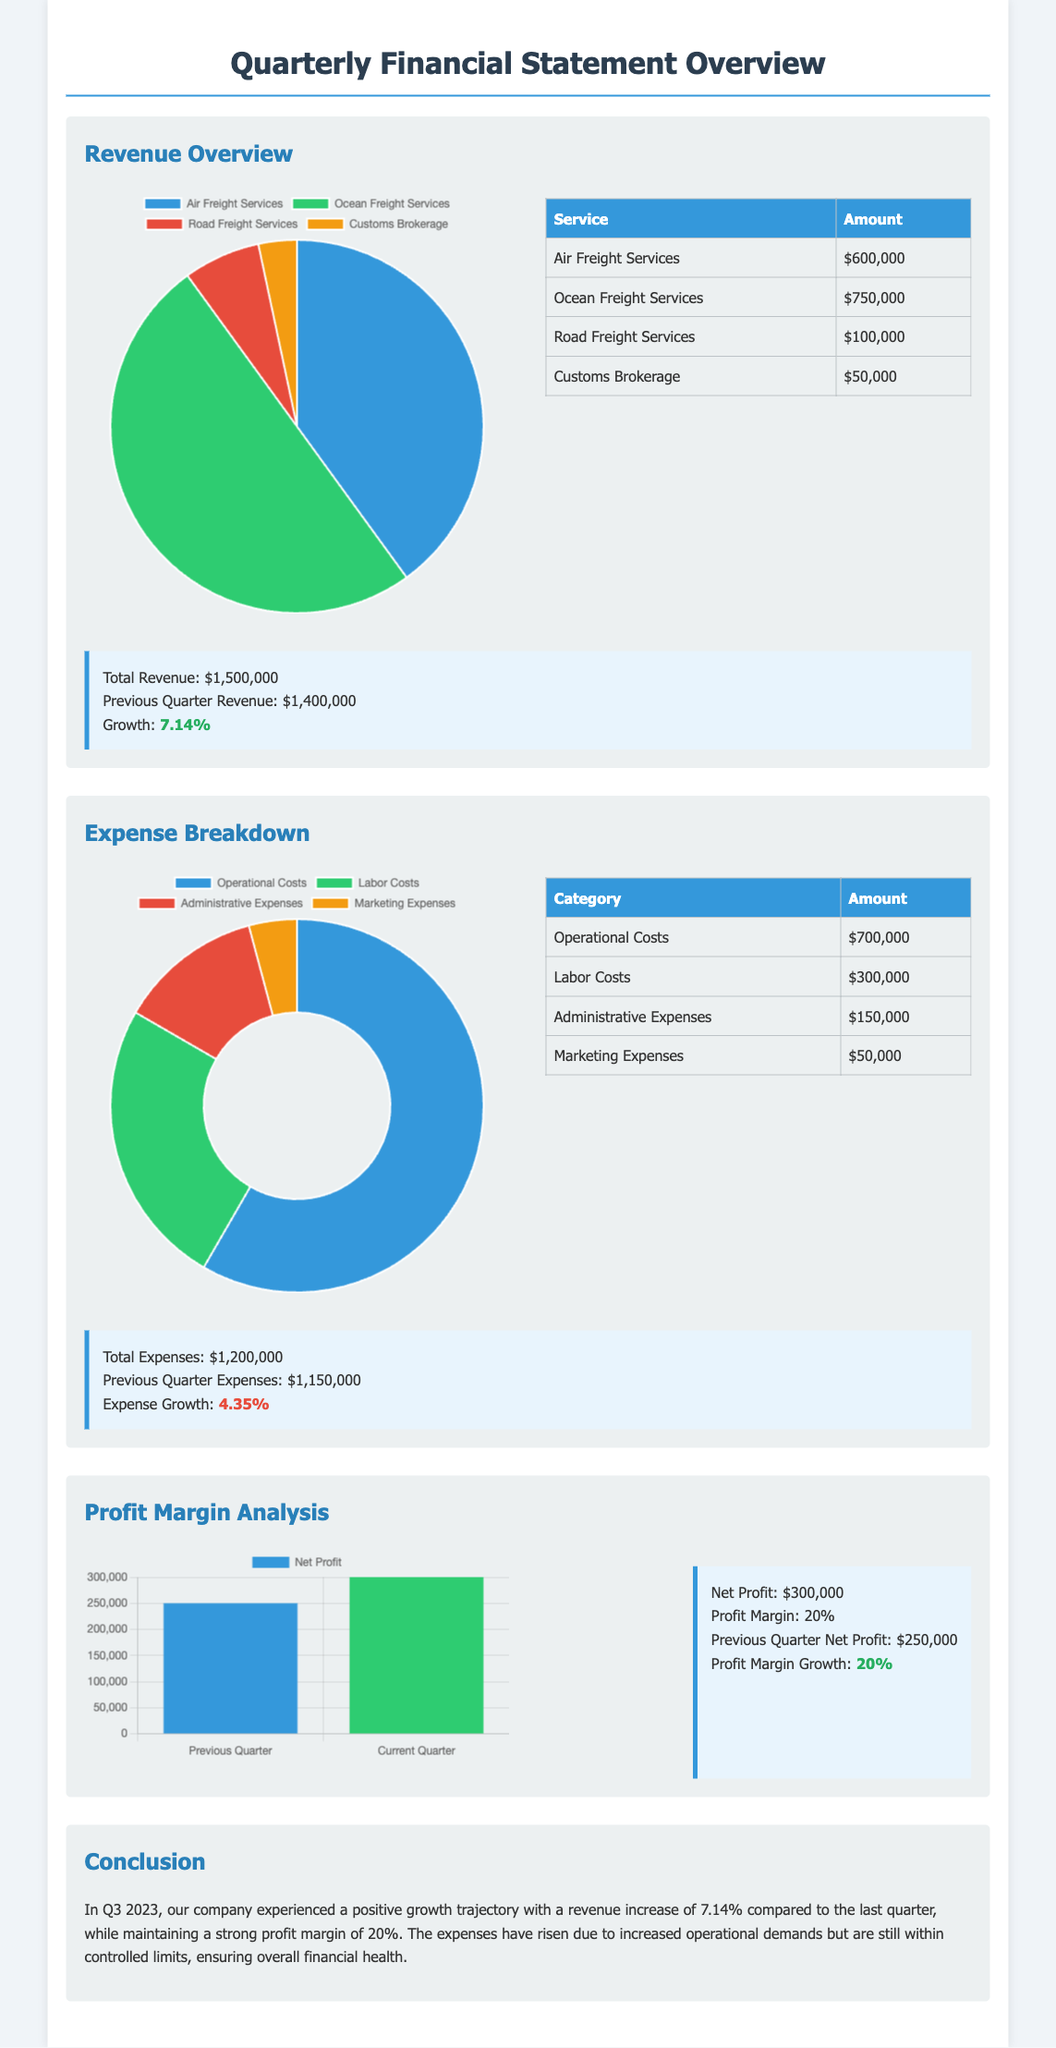What is the total revenue? The total revenue is provided in the summary section where all revenue sources are added up to $1,500,000.
Answer: $1,500,000 What is the growth percentage of revenue? The growth percentage of revenue is mentioned in the summary, comparing the current quarter to the previous quarter, which is 7.14%.
Answer: 7.14% What are the total expenses? The total expenses are listed in the summary section as being $1,200,000.
Answer: $1,200,000 Which service generated the highest revenue? The service with the highest revenue is found in the revenue breakdown, which is Ocean Freight Services with $750,000.
Answer: Ocean Freight Services What was the net profit for the current quarter? The net profit is detailed in the profit margin analysis section as $300,000.
Answer: $300,000 What is the profit margin percentage? The profit margin percentage is stated in the profit margin analysis section to be 20%.
Answer: 20% What were the previous quarter's expenses? The previous quarter's expenses are compared in the summary section where it states $1,150,000.
Answer: $1,150,000 Which category has the highest operational costs? The highest operational costs category is found in the expense breakdown, which is Operational Costs at $700,000.
Answer: Operational Costs What was the increase in net profit compared to the previous quarter? The increase in net profit is calculated by comparing current net profit of $300,000 against the previous quarter's profit of $250,000, resulting in an increase of $50,000.
Answer: $50,000 